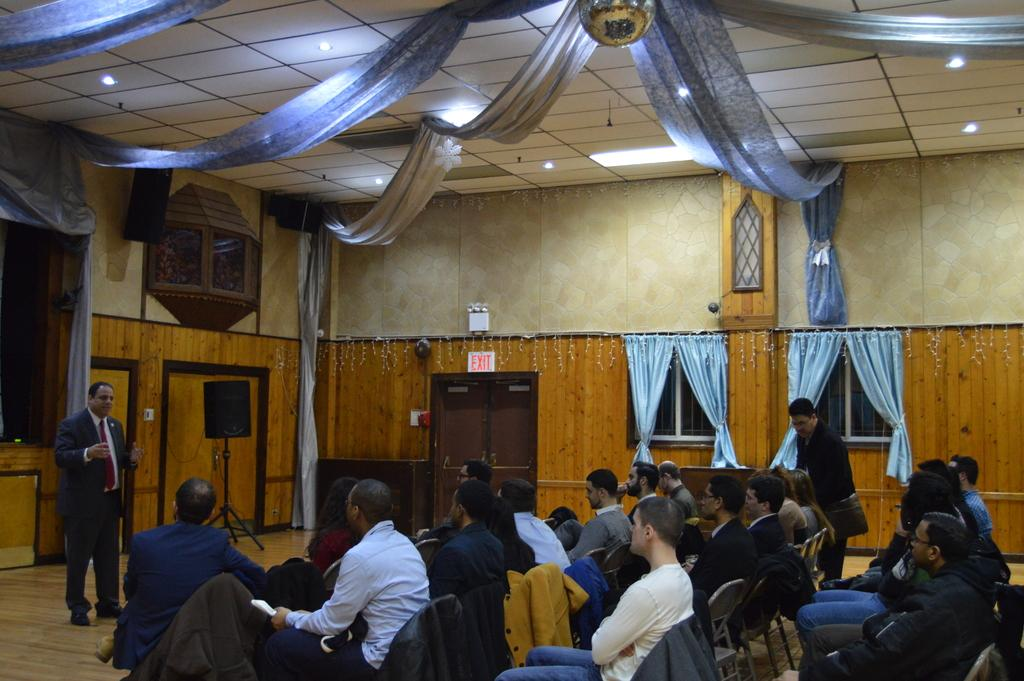How many people are in the image? There is a group of people in the image, but the exact number is not specified. What are some of the people in the image doing? Some people are sitting on chairs, while others are standing. What can be seen in the background of the image? There is a door, windows, curtains, and lights in the background of the image. How does the regret roll through the gate in the image? There is no regret or gate present in the image; it features a group of people with some sitting and others standing, along with a background that includes a door, windows, curtains, and lights. 